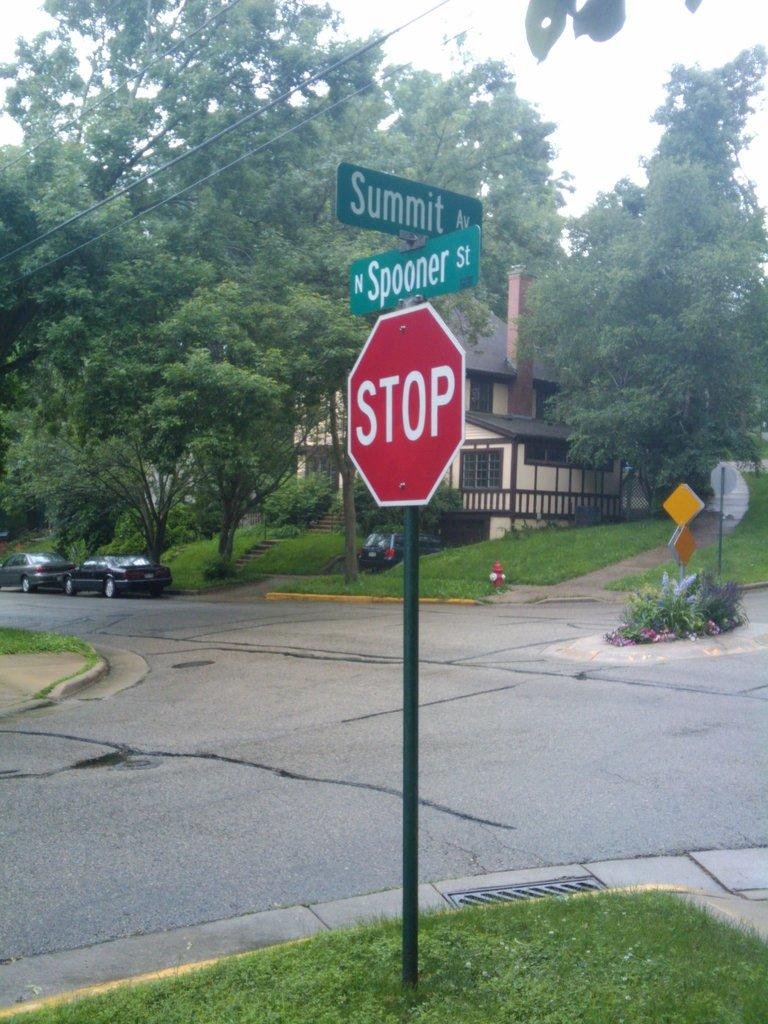Provide a one-sentence caption for the provided image. an intersection of two streets, summit and spooner st. 